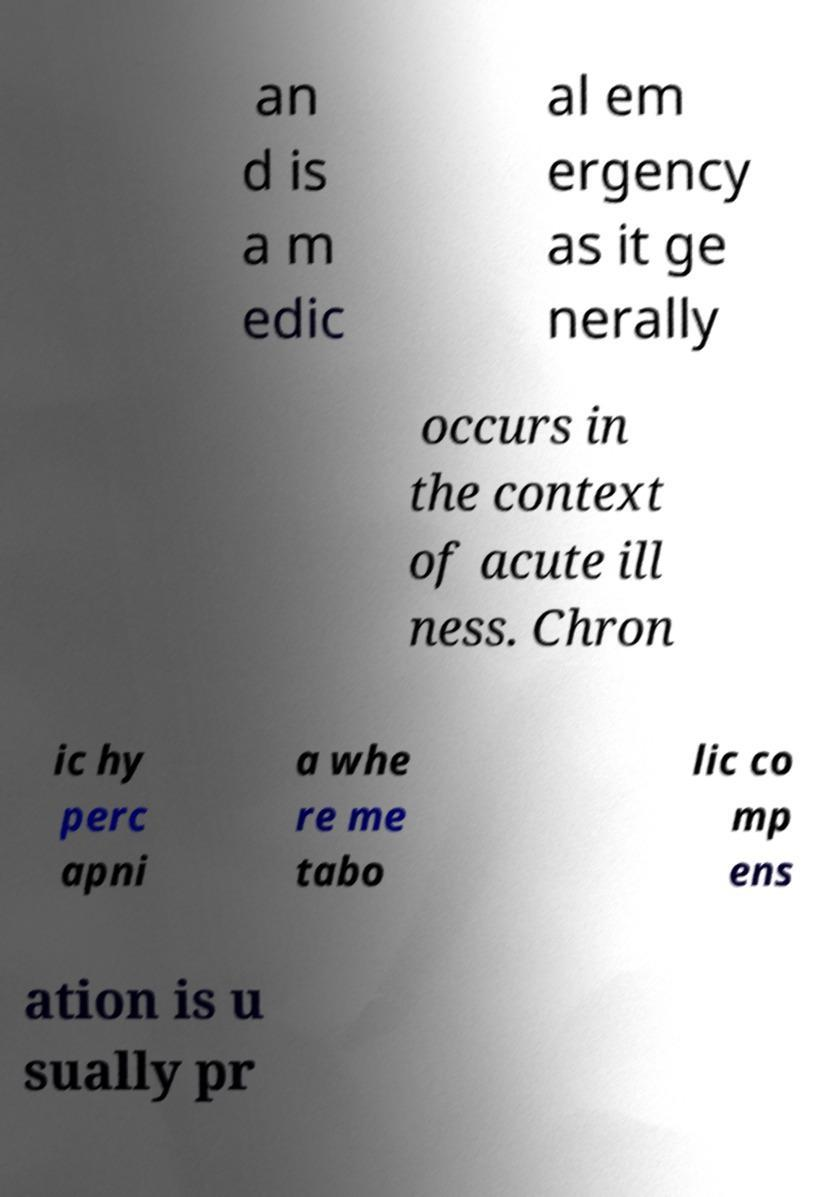Could you extract and type out the text from this image? an d is a m edic al em ergency as it ge nerally occurs in the context of acute ill ness. Chron ic hy perc apni a whe re me tabo lic co mp ens ation is u sually pr 